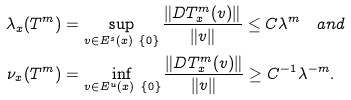<formula> <loc_0><loc_0><loc_500><loc_500>\lambda _ { x } ( T ^ { m } ) & = \sup _ { v \in E ^ { s } ( x ) \ \{ 0 \} } \frac { \| D T ^ { m } _ { x } ( v ) \| } { \| v \| } \leq C \lambda ^ { m } \quad a n d \\ \nu _ { x } ( T ^ { m } ) & = \inf _ { v \in E ^ { u } ( x ) \ \{ 0 \} } \frac { \| D T ^ { m } _ { x } ( v ) \| } { \| v \| } \geq C ^ { - 1 } \lambda ^ { - m } .</formula> 